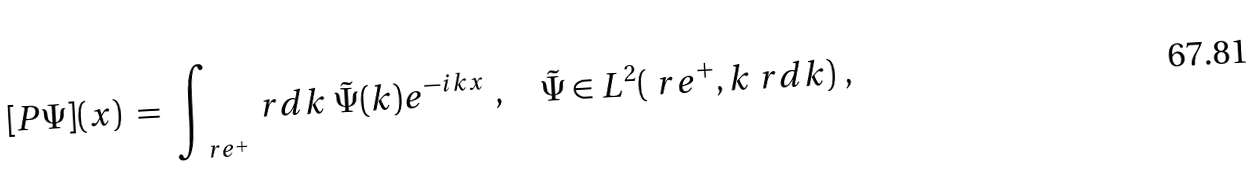<formula> <loc_0><loc_0><loc_500><loc_500>[ P \Psi ] ( x ) \ = \ \int _ { \ r e ^ { + } } \ r d k \ \tilde { \Psi } ( k ) e ^ { - i k x } \ , \quad \tilde { \Psi } \in L ^ { 2 } ( \ r e ^ { + } , k \ r d k ) \ ,</formula> 